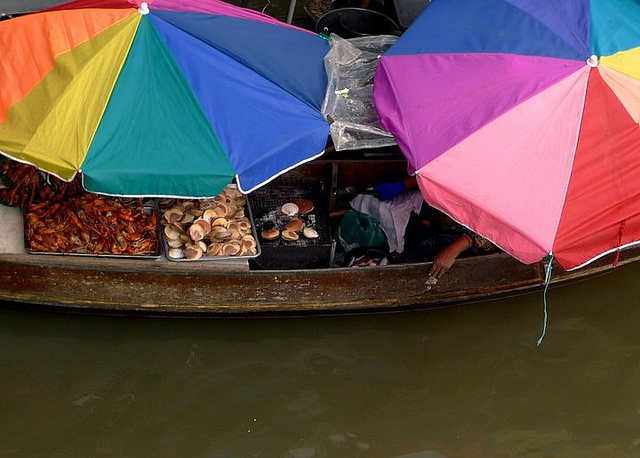Describe the objects in this image and their specific colors. I can see umbrella in gray, lightpink, salmon, magenta, and blue tones, umbrella in gray, teal, blue, and orange tones, boat in gray, black, and maroon tones, and people in gray, black, maroon, navy, and brown tones in this image. 